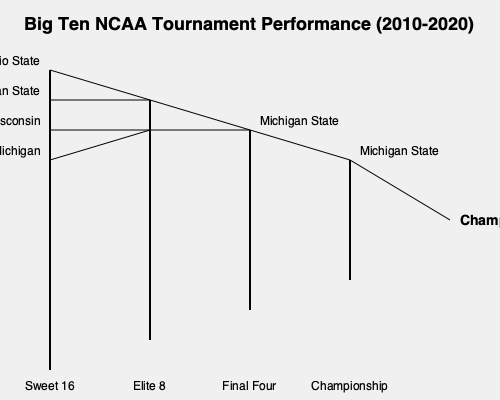Based on the bracket-style visualization of Big Ten NCAA Tournament performance from 2010 to 2020, which team had the most success in reaching the Final Four, and how does Ohio State's performance compare? To answer this question, let's analyze the bracket-style visualization step-by-step:

1. The bracket shows the performance of Big Ten teams in the NCAA Tournament from 2010 to 2020.

2. We can see four teams represented in the Sweet 16 round:
   - Ohio State
   - Michigan State
   - Wisconsin
   - Michigan

3. Moving to the Elite 8, we see:
   - Michigan State
   - A combination of Wisconsin and Michigan

4. In the Final Four, Michigan State is the only team represented.

5. Michigan State then advances to the Championship game.

6. Comparing Ohio State's performance:
   - Ohio State is shown reaching the Sweet 16
   - They do not appear in later rounds of the tournament

7. Michigan State's performance:
   - Reaches the Sweet 16
   - Advances to the Elite 8
   - Makes it to the Final Four
   - Reaches the Championship game

Based on this visualization, Michigan State had the most success in reaching the Final Four among Big Ten teams during this period. They are the only team shown to consistently advance through each round, including reaching the Championship game.

Ohio State's performance, in comparison, is limited to reaching the Sweet 16. They did not advance as far as Michigan State in this representation of tournament success over the decade.
Answer: Michigan State had the most Final Four success; Ohio State reached Sweet 16. 